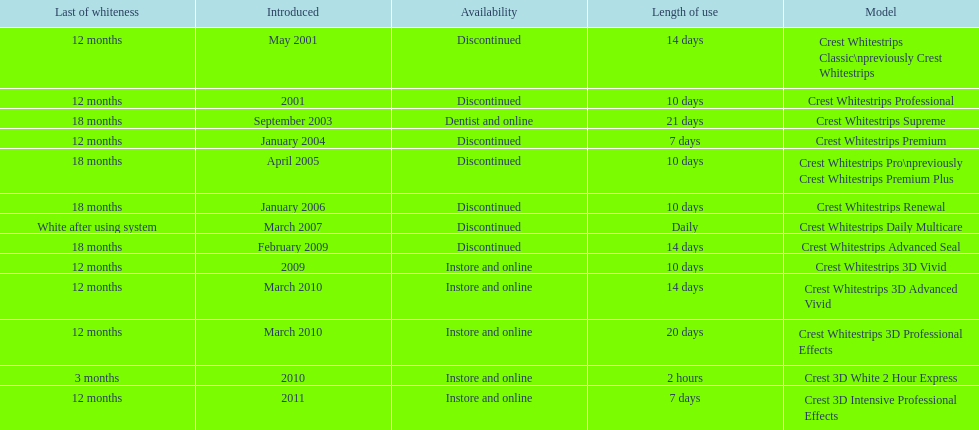How many products have been discontinued? 7. 